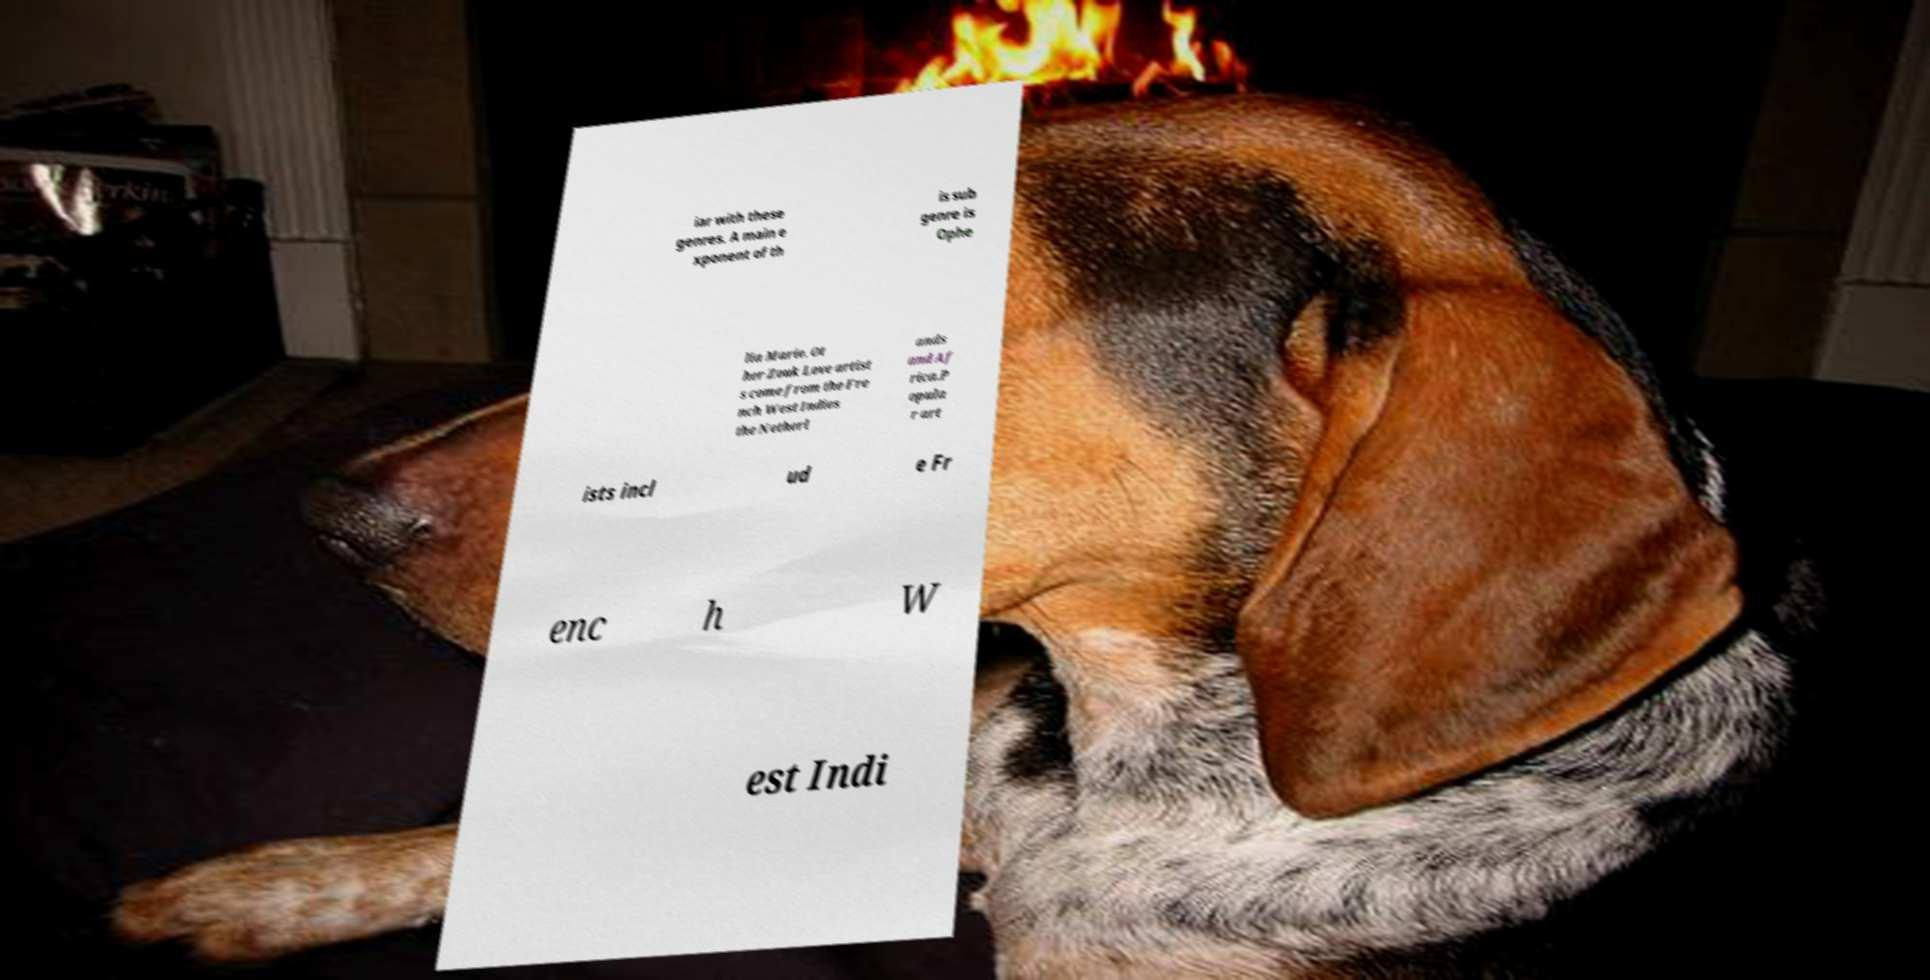Please read and relay the text visible in this image. What does it say? iar with these genres. A main e xponent of th is sub genre is Ophe lia Marie. Ot her Zouk Love artist s come from the Fre nch West Indies the Netherl ands and Af rica.P opula r art ists incl ud e Fr enc h W est Indi 